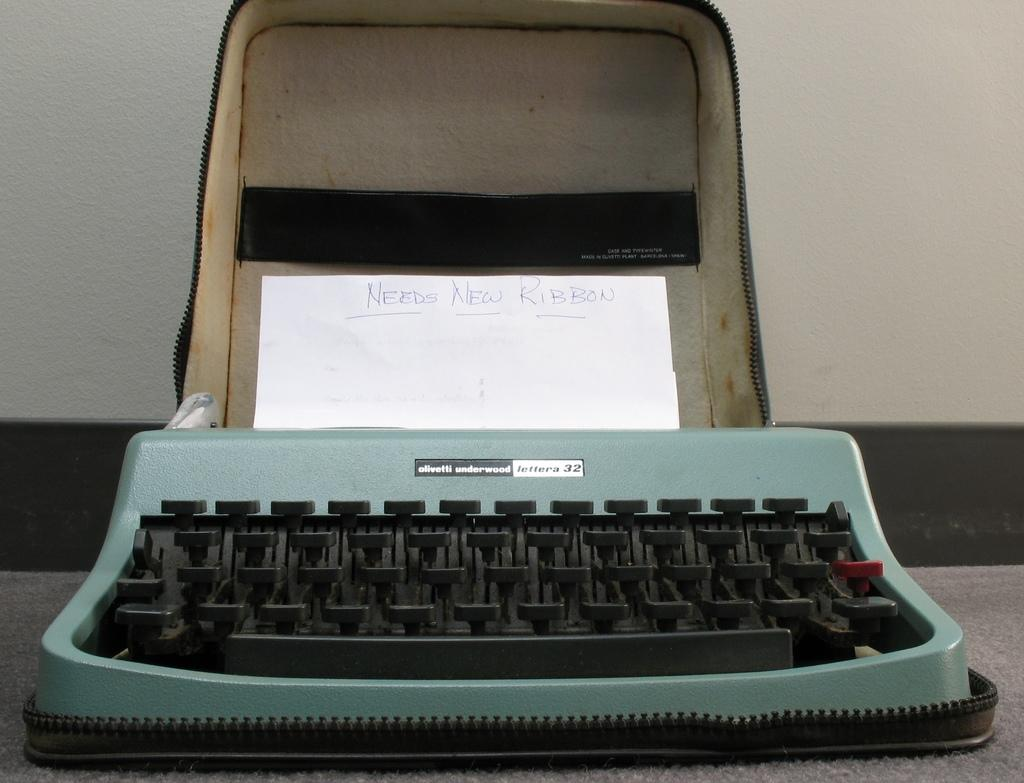<image>
Provide a brief description of the given image. a greenish typewriter with a paper sticking out saying needs ribbon 